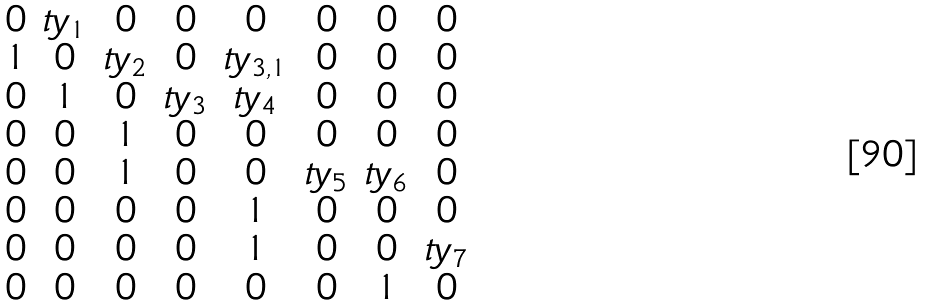<formula> <loc_0><loc_0><loc_500><loc_500>\begin{matrix} 0 & t y _ { 1 } & 0 & 0 & 0 & 0 & 0 & 0 \\ 1 & 0 & t y _ { 2 } & 0 & t y _ { 3 , 1 } & 0 & 0 & 0 \\ 0 & 1 & 0 & t y _ { 3 } & t y _ { 4 } & 0 & 0 & 0 \\ 0 & 0 & 1 & 0 & 0 & 0 & 0 & 0 \\ 0 & 0 & 1 & 0 & 0 & t y _ { 5 } & t y _ { 6 } & 0 \\ 0 & 0 & 0 & 0 & 1 & 0 & 0 & 0 \\ 0 & 0 & 0 & 0 & 1 & 0 & 0 & t y _ { 7 } \\ 0 & 0 & 0 & 0 & 0 & 0 & 1 & 0 \end{matrix}</formula> 